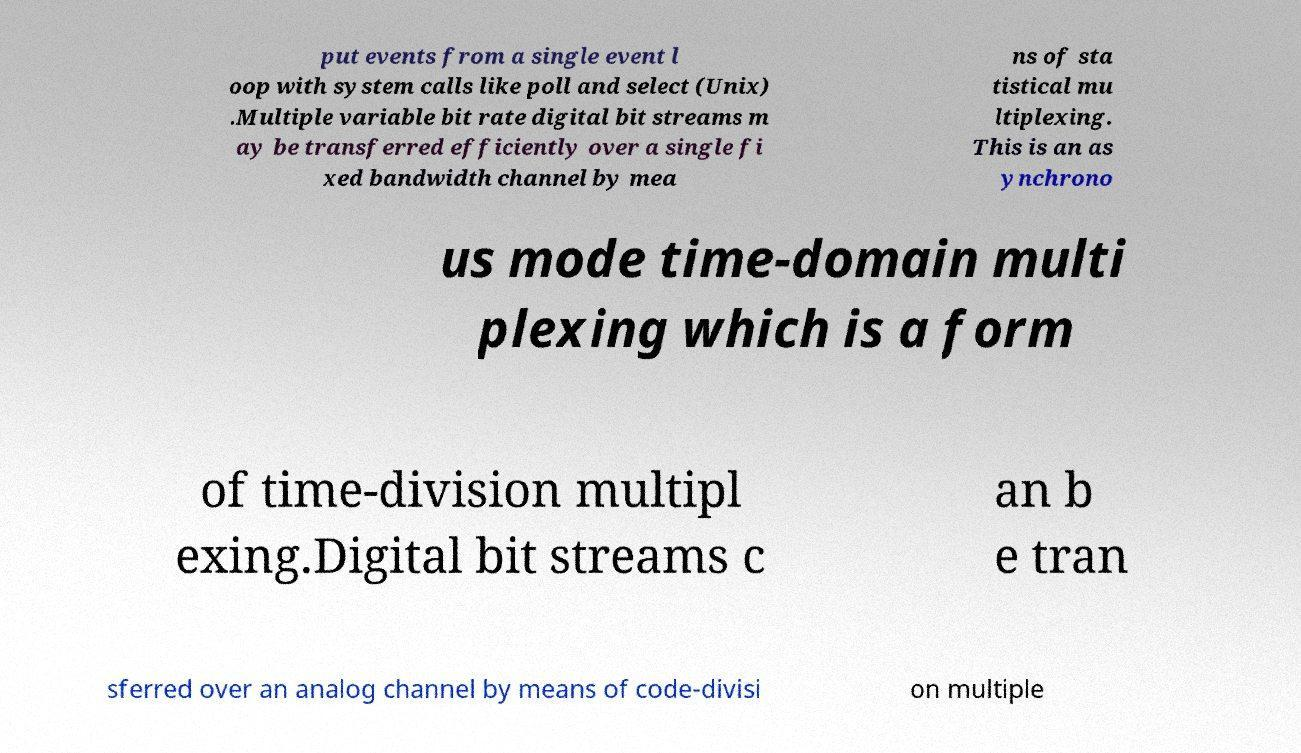Could you extract and type out the text from this image? put events from a single event l oop with system calls like poll and select (Unix) .Multiple variable bit rate digital bit streams m ay be transferred efficiently over a single fi xed bandwidth channel by mea ns of sta tistical mu ltiplexing. This is an as ynchrono us mode time-domain multi plexing which is a form of time-division multipl exing.Digital bit streams c an b e tran sferred over an analog channel by means of code-divisi on multiple 